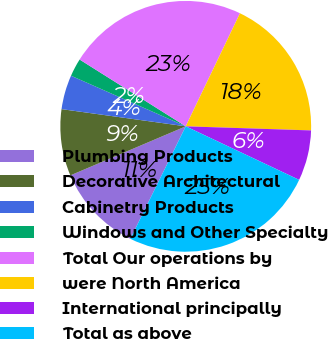Convert chart. <chart><loc_0><loc_0><loc_500><loc_500><pie_chart><fcel>Plumbing Products<fcel>Decorative Architectural<fcel>Cabinetry Products<fcel>Windows and Other Specialty<fcel>Total Our operations by<fcel>were North America<fcel>International principally<fcel>Total as above<nl><fcel>11.32%<fcel>8.59%<fcel>4.42%<fcel>2.33%<fcel>23.18%<fcel>18.4%<fcel>6.5%<fcel>25.26%<nl></chart> 